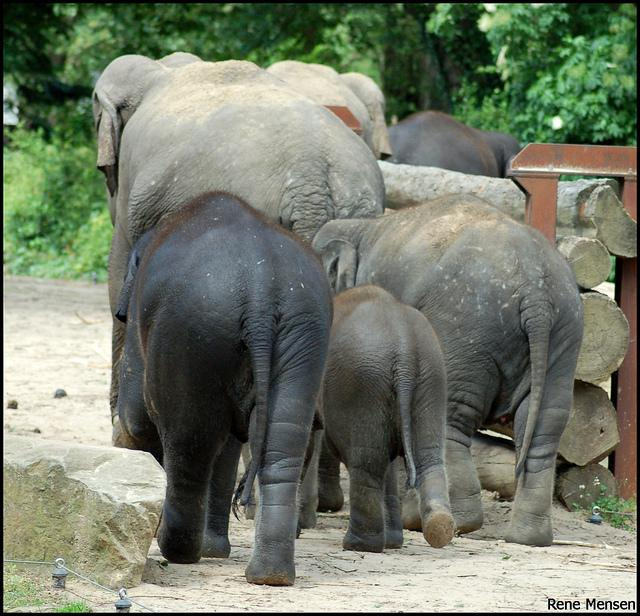What is this group of animals called? Please explain your reasoning. herd. There is a group of elephants. 